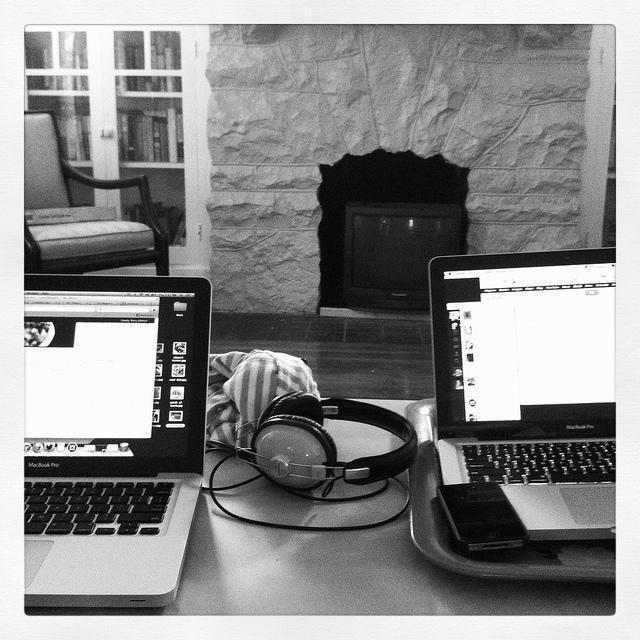How many computers are shown?
Give a very brief answer. 2. How many laptops can you see?
Give a very brief answer. 2. How many zebras are drinking water?
Give a very brief answer. 0. 